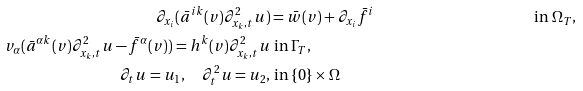Convert formula to latex. <formula><loc_0><loc_0><loc_500><loc_500>\partial _ { x _ { i } } ( \bar { a } ^ { i k } ( v ) \partial ^ { 2 } _ { x _ { k } , t } u ) & = \bar { w } ( v ) + \partial _ { x _ { i } } \bar { f } ^ { i } & \text { in } \Omega _ { T } , \\ v _ { \alpha } ( \bar { a } ^ { \alpha k } ( v ) \partial ^ { 2 } _ { x _ { k } , t } u - \bar { f } ^ { \alpha } ( v ) ) = h ^ { k } ( v ) \partial ^ { 2 } _ { x _ { k } , t } u & \text { in } \Gamma _ { T } , \\ \partial _ { t } u = u _ { 1 } , \quad \partial _ { t } ^ { 2 } u = u _ { 2 } , & \text { in } \{ 0 \} \times \Omega</formula> 